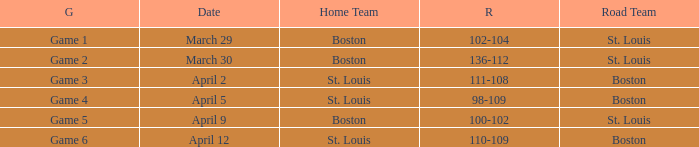What is the Result of Game 3? 111-108. I'm looking to parse the entire table for insights. Could you assist me with that? {'header': ['G', 'Date', 'Home Team', 'R', 'Road Team'], 'rows': [['Game 1', 'March 29', 'Boston', '102-104', 'St. Louis'], ['Game 2', 'March 30', 'Boston', '136-112', 'St. Louis'], ['Game 3', 'April 2', 'St. Louis', '111-108', 'Boston'], ['Game 4', 'April 5', 'St. Louis', '98-109', 'Boston'], ['Game 5', 'April 9', 'Boston', '100-102', 'St. Louis'], ['Game 6', 'April 12', 'St. Louis', '110-109', 'Boston']]} 